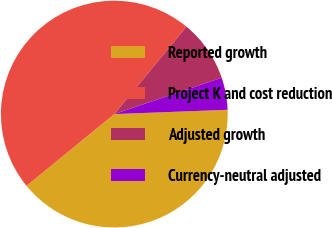<chart> <loc_0><loc_0><loc_500><loc_500><pie_chart><fcel>Reported growth<fcel>Project K and cost reduction<fcel>Adjusted growth<fcel>Currency-neutral adjusted<nl><fcel>39.7%<fcel>46.89%<fcel>8.82%<fcel>4.59%<nl></chart> 